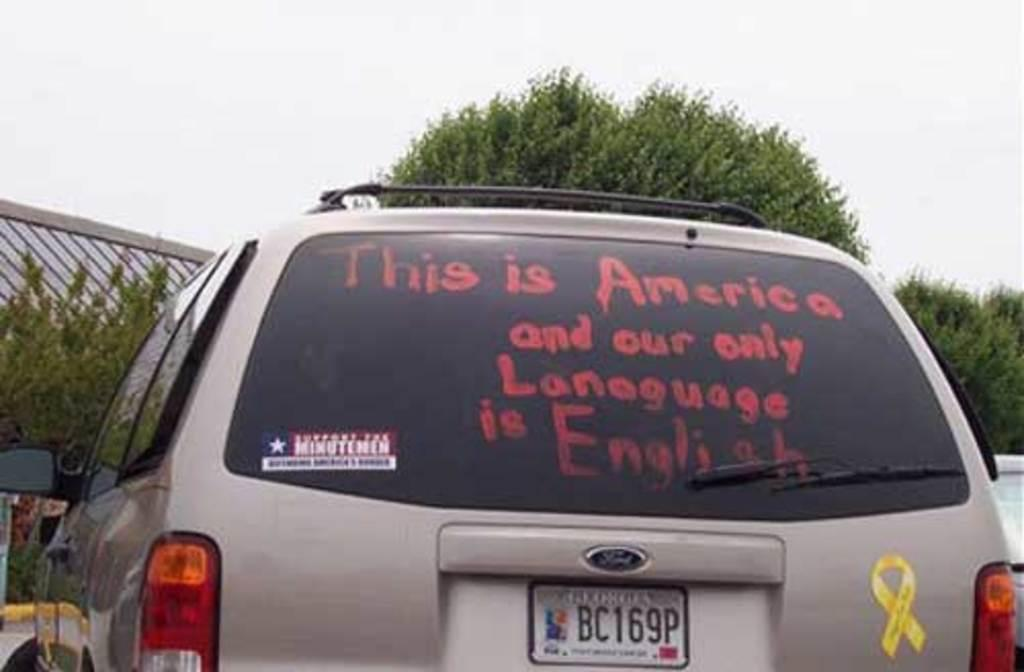Provide a one-sentence caption for the provided image. Image displays silver vehicle with the text "This is America and your only language is English" written on the rear view window. 